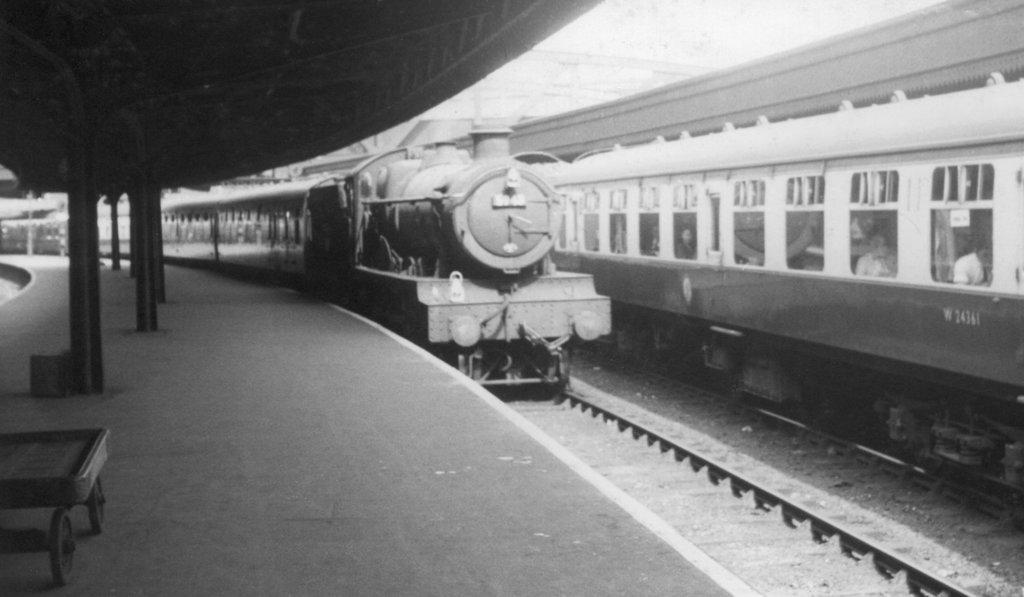What is the color scheme of the image? The image is black and white. What can be seen moving on the track in the image? There are two trains moving on the track. What is located on the left side of the image? There is a platform on the left side of the image. Can you describe an object with a Tyre in the image? There is an object with a Tyre in the image, but it is not clear what it is. What type of structure can be seen in the image? There is a shed in the image. What architectural elements are present in the image? There are pillars in the image. How many muscles can be seen flexing on the vacationers in the image? There are no vacationers or muscles visible in the image; it features a train track, platform, shed, and pillars. 